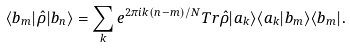<formula> <loc_0><loc_0><loc_500><loc_500>\langle b _ { m } | \hat { \rho } | b _ { n } \rangle = \sum _ { k } e ^ { 2 \pi i k ( n - m ) / N } T r \hat { \rho } | a _ { k } \rangle \langle a _ { k } | b _ { m } \rangle \langle b _ { m } | .</formula> 